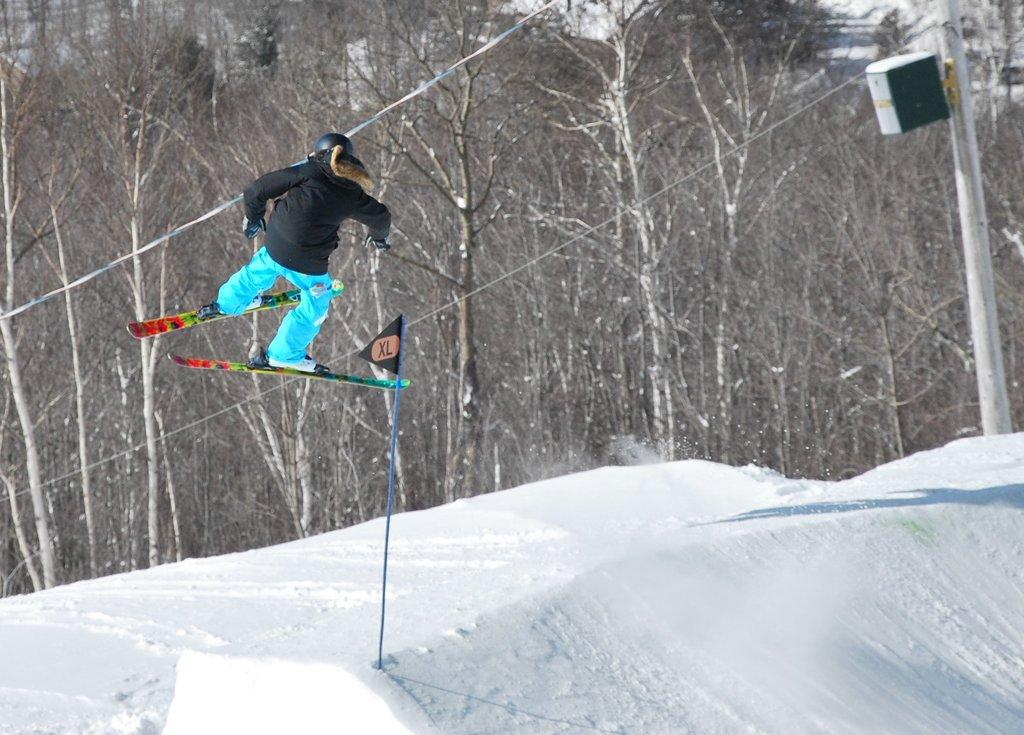What activity is the person in the image engaged in? The person is skiing in the image. What equipment is the person using for skiing? The person is using skis for skiing. On what surface is the skiing taking place? The skiing is taking place on snow. What can be seen in the background of the image? There are trees, a pole, and cables in the background of the image. What type of clover can be seen growing on the edge of the ski slope in the image? There is no clover visible in the image, and the ski slope does not have an edge as it is on snow. 